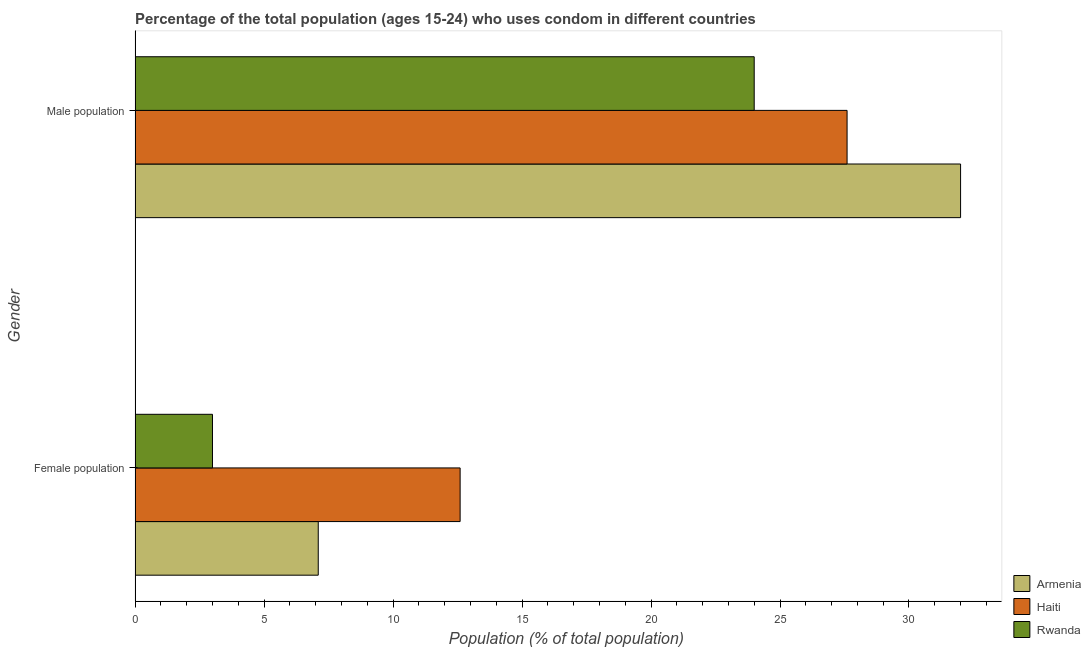Are the number of bars per tick equal to the number of legend labels?
Keep it short and to the point. Yes. How many bars are there on the 2nd tick from the top?
Your answer should be compact. 3. What is the label of the 2nd group of bars from the top?
Ensure brevity in your answer.  Female population. What is the female population in Haiti?
Your response must be concise. 12.6. Across all countries, what is the maximum female population?
Provide a short and direct response. 12.6. Across all countries, what is the minimum female population?
Offer a very short reply. 3. In which country was the male population maximum?
Your answer should be compact. Armenia. In which country was the male population minimum?
Provide a short and direct response. Rwanda. What is the total male population in the graph?
Keep it short and to the point. 83.6. What is the average female population per country?
Offer a terse response. 7.57. What is the difference between the female population and male population in Haiti?
Your response must be concise. -15. What is the ratio of the male population in Haiti to that in Rwanda?
Provide a succinct answer. 1.15. In how many countries, is the female population greater than the average female population taken over all countries?
Provide a succinct answer. 1. What does the 3rd bar from the top in Female population represents?
Your answer should be compact. Armenia. What does the 3rd bar from the bottom in Male population represents?
Provide a succinct answer. Rwanda. How many countries are there in the graph?
Keep it short and to the point. 3. How are the legend labels stacked?
Your answer should be very brief. Vertical. What is the title of the graph?
Provide a succinct answer. Percentage of the total population (ages 15-24) who uses condom in different countries. What is the label or title of the X-axis?
Keep it short and to the point. Population (% of total population) . What is the Population (% of total population)  of Haiti in Female population?
Offer a terse response. 12.6. What is the Population (% of total population)  in Haiti in Male population?
Keep it short and to the point. 27.6. What is the Population (% of total population)  in Rwanda in Male population?
Offer a very short reply. 24. Across all Gender, what is the maximum Population (% of total population)  of Armenia?
Offer a terse response. 32. Across all Gender, what is the maximum Population (% of total population)  of Haiti?
Give a very brief answer. 27.6. Across all Gender, what is the maximum Population (% of total population)  in Rwanda?
Your response must be concise. 24. Across all Gender, what is the minimum Population (% of total population)  in Armenia?
Keep it short and to the point. 7.1. What is the total Population (% of total population)  of Armenia in the graph?
Your answer should be very brief. 39.1. What is the total Population (% of total population)  in Haiti in the graph?
Give a very brief answer. 40.2. What is the difference between the Population (% of total population)  in Armenia in Female population and that in Male population?
Keep it short and to the point. -24.9. What is the difference between the Population (% of total population)  in Haiti in Female population and that in Male population?
Offer a terse response. -15. What is the difference between the Population (% of total population)  of Rwanda in Female population and that in Male population?
Offer a terse response. -21. What is the difference between the Population (% of total population)  of Armenia in Female population and the Population (% of total population)  of Haiti in Male population?
Your answer should be compact. -20.5. What is the difference between the Population (% of total population)  of Armenia in Female population and the Population (% of total population)  of Rwanda in Male population?
Ensure brevity in your answer.  -16.9. What is the average Population (% of total population)  of Armenia per Gender?
Offer a terse response. 19.55. What is the average Population (% of total population)  in Haiti per Gender?
Provide a short and direct response. 20.1. What is the average Population (% of total population)  in Rwanda per Gender?
Offer a terse response. 13.5. What is the difference between the Population (% of total population)  in Armenia and Population (% of total population)  in Haiti in Female population?
Keep it short and to the point. -5.5. What is the difference between the Population (% of total population)  of Haiti and Population (% of total population)  of Rwanda in Female population?
Your response must be concise. 9.6. What is the difference between the Population (% of total population)  of Armenia and Population (% of total population)  of Haiti in Male population?
Offer a very short reply. 4.4. What is the difference between the Population (% of total population)  in Armenia and Population (% of total population)  in Rwanda in Male population?
Give a very brief answer. 8. What is the ratio of the Population (% of total population)  in Armenia in Female population to that in Male population?
Keep it short and to the point. 0.22. What is the ratio of the Population (% of total population)  in Haiti in Female population to that in Male population?
Keep it short and to the point. 0.46. What is the difference between the highest and the second highest Population (% of total population)  of Armenia?
Keep it short and to the point. 24.9. What is the difference between the highest and the second highest Population (% of total population)  in Rwanda?
Your response must be concise. 21. What is the difference between the highest and the lowest Population (% of total population)  in Armenia?
Keep it short and to the point. 24.9. 